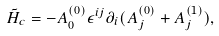Convert formula to latex. <formula><loc_0><loc_0><loc_500><loc_500>\tilde { H } _ { c } = - A _ { 0 } ^ { ( 0 ) } \epsilon ^ { i j } \partial _ { i } ( A _ { j } ^ { ( 0 ) } + A _ { j } ^ { ( 1 ) } ) ,</formula> 